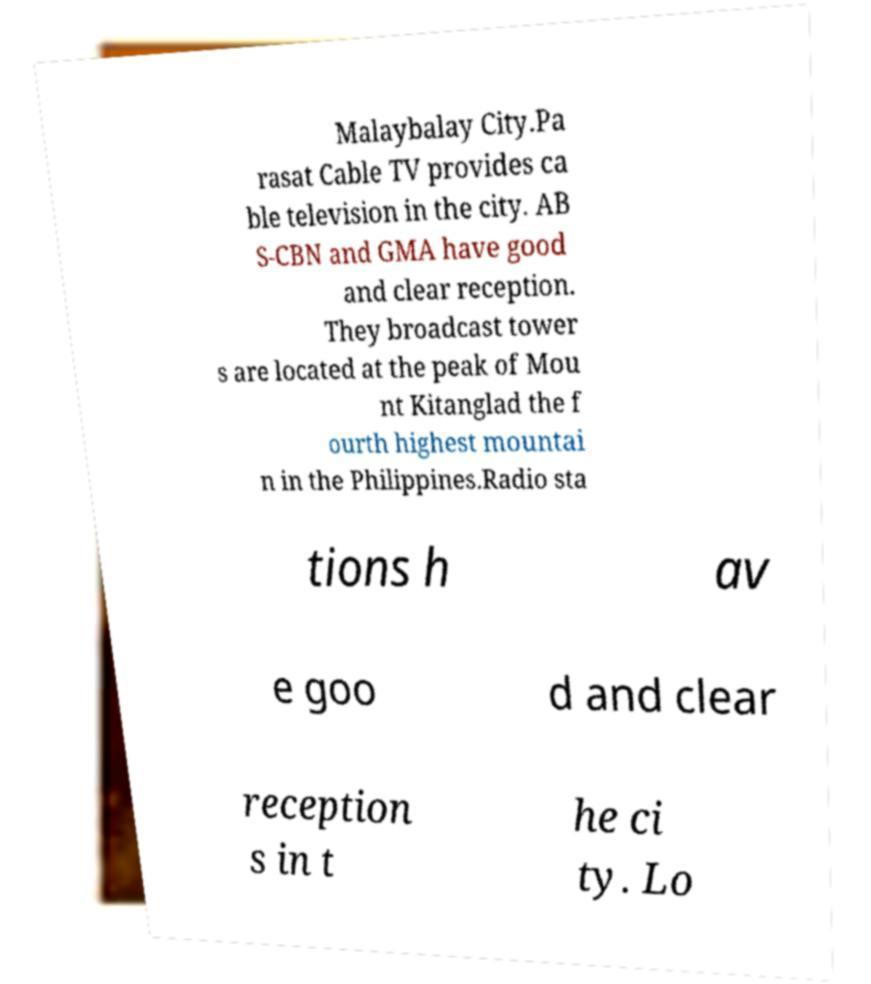Can you read and provide the text displayed in the image?This photo seems to have some interesting text. Can you extract and type it out for me? Malaybalay City.Pa rasat Cable TV provides ca ble television in the city. AB S-CBN and GMA have good and clear reception. They broadcast tower s are located at the peak of Mou nt Kitanglad the f ourth highest mountai n in the Philippines.Radio sta tions h av e goo d and clear reception s in t he ci ty. Lo 